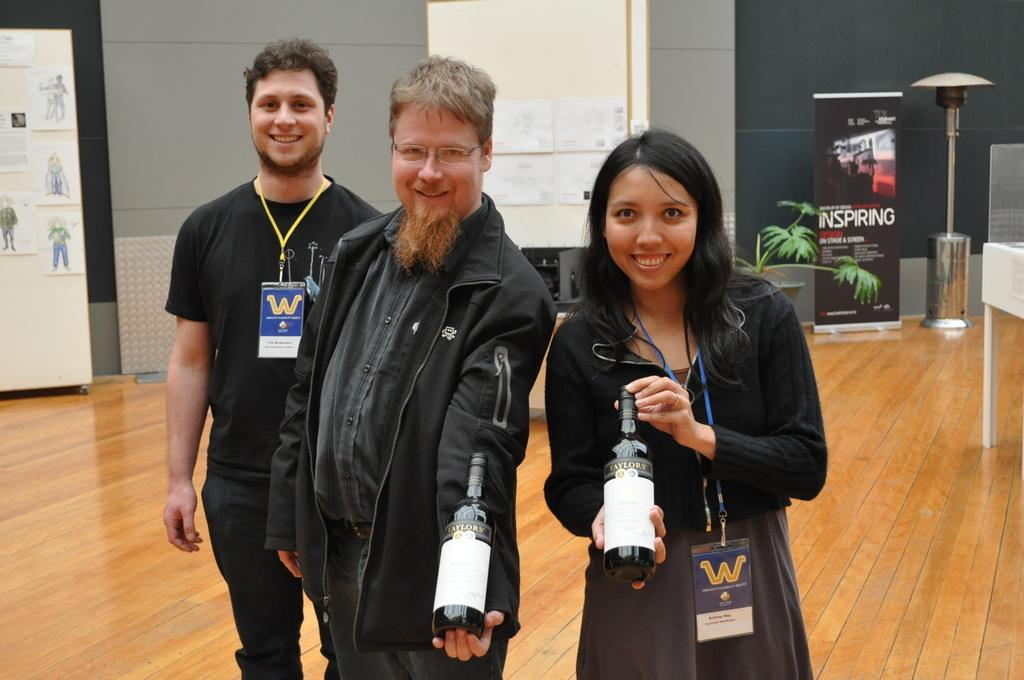What are the persons in the image holding? The persons in the image are holding beverage bottles. What can be seen in the background of the image? There is a wall, an advertisement, and a house plant in the background of the image. What is the texture of the earthquake in the image? There is no earthquake present in the image, so it is not possible to determine its texture. 